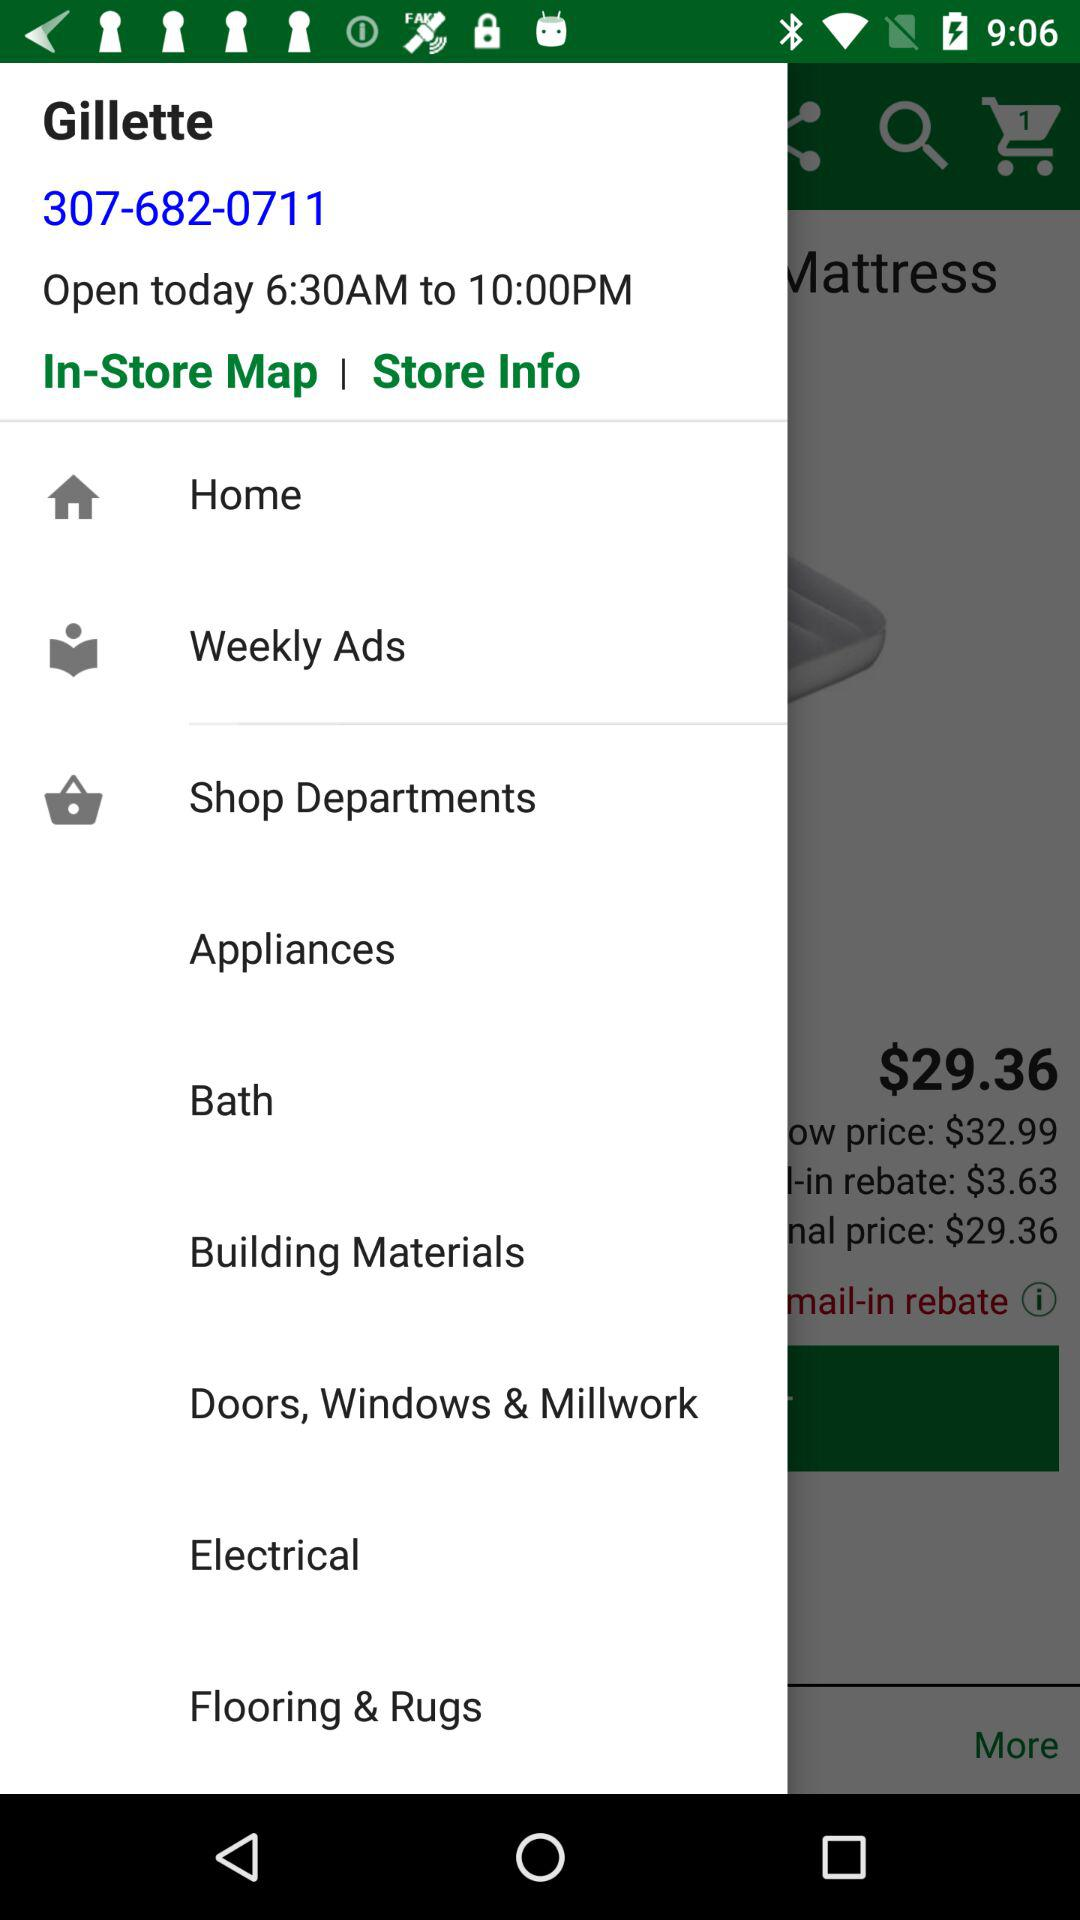What is the contact number for the Gillette store? The contact number is 307-682-0711. 